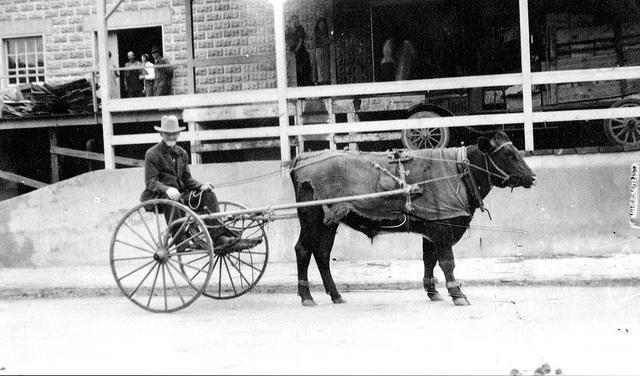How many people would fit on this carriage?
Give a very brief answer. 1. 